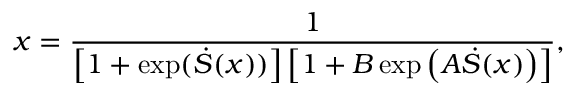<formula> <loc_0><loc_0><loc_500><loc_500>x = \frac { 1 } { \left [ 1 + \exp ( \dot { S } ( x ) ) \right ] \left [ 1 + B \exp \left ( A \dot { S } ( x ) \right ) \right ] } ,</formula> 